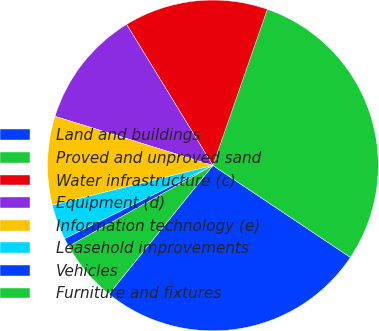<chart> <loc_0><loc_0><loc_500><loc_500><pie_chart><fcel>Land and buildings<fcel>Proved and unproved sand<fcel>Water infrastructure (c)<fcel>Equipment (d)<fcel>Information technology (e)<fcel>Leasehold improvements<fcel>Vehicles<fcel>Furniture and fixtures<nl><fcel>26.43%<fcel>29.04%<fcel>14.07%<fcel>11.46%<fcel>8.66%<fcel>3.44%<fcel>0.83%<fcel>6.05%<nl></chart> 